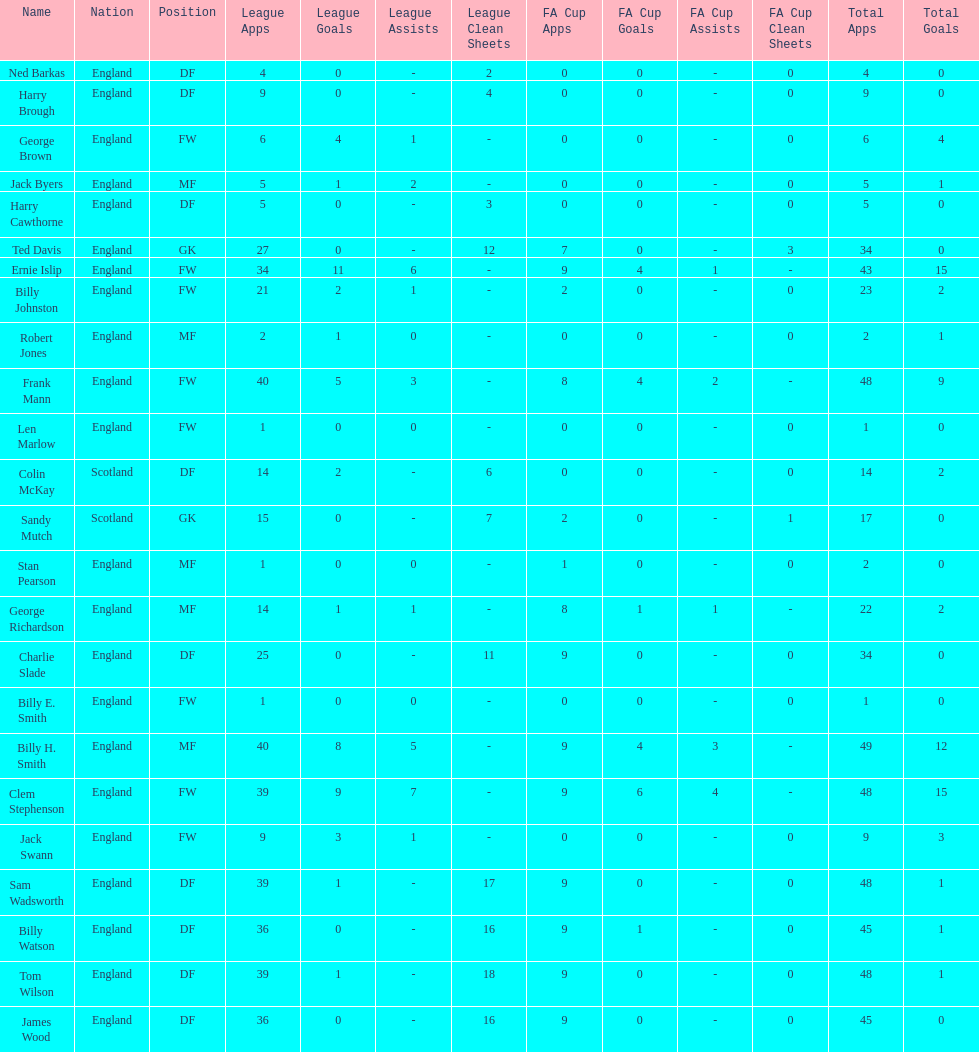What is the last name listed on this chart? James Wood. 